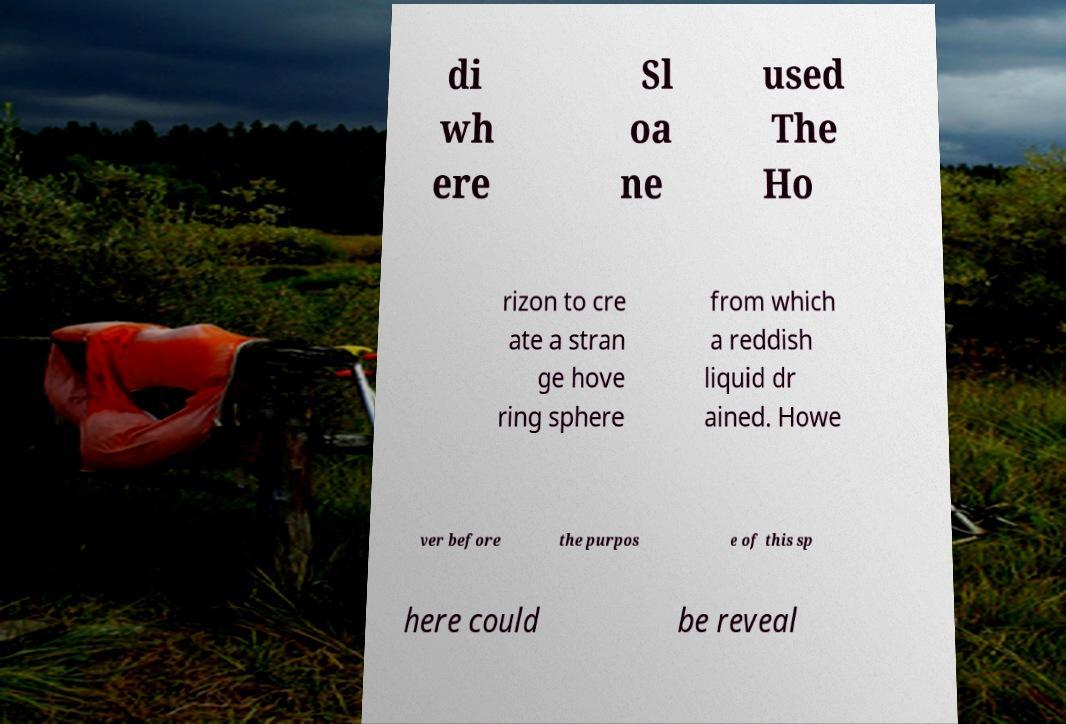There's text embedded in this image that I need extracted. Can you transcribe it verbatim? di wh ere Sl oa ne used The Ho rizon to cre ate a stran ge hove ring sphere from which a reddish liquid dr ained. Howe ver before the purpos e of this sp here could be reveal 